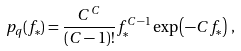Convert formula to latex. <formula><loc_0><loc_0><loc_500><loc_500>p _ { q } ( f _ { * } ) = \frac { C ^ { C } } { ( C - 1 ) ! } f _ { * } ^ { C - 1 } \exp \left ( - C f _ { * } \right ) \, ,</formula> 